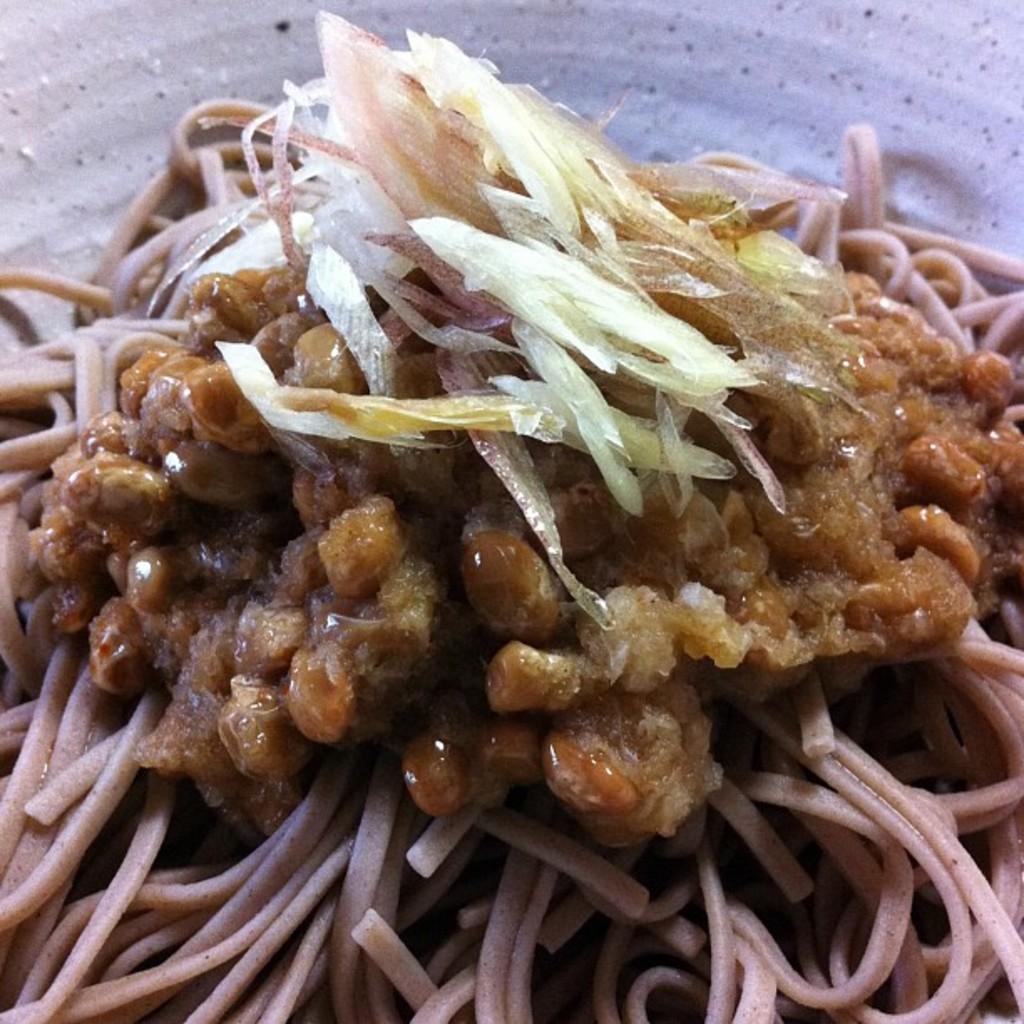Could you give a brief overview of what you see in this image? In this image, there is some food kept in a plate. 